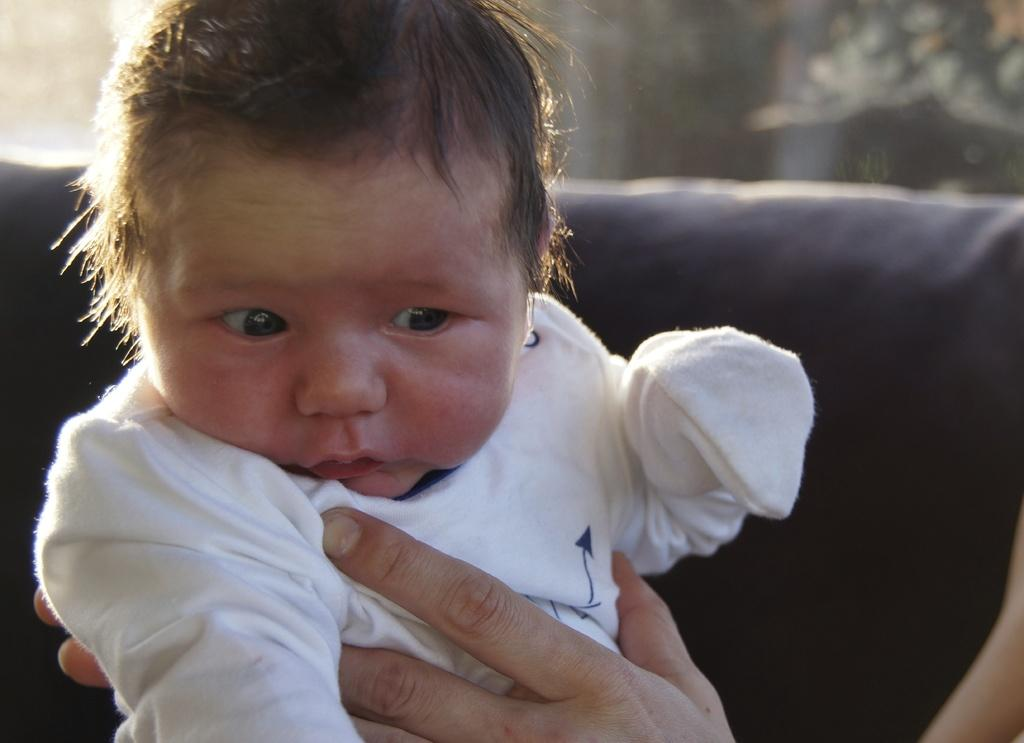What is happening on the right side of the image? There is a person holding a baby on the right side of the image. What is the baby wearing? The baby is wearing a white dress. What can be seen in the background of the image? There are trees and other objects in the background of the image. What type of iron is present in the image? There is no iron present in the image. What kind of beast can be seen interacting with the baby in the image? There is no beast present in the image; it features a person holding a baby. 